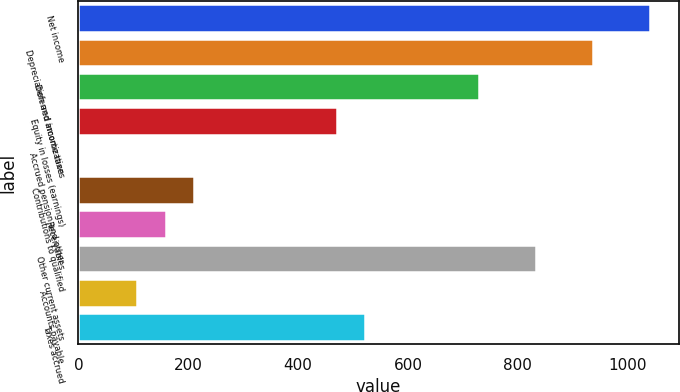Convert chart. <chart><loc_0><loc_0><loc_500><loc_500><bar_chart><fcel>Net income<fcel>Depreciation and amortization<fcel>Deferred income taxes<fcel>Equity in losses (earnings)<fcel>Accrued pension and other<fcel>Contributions to qualified<fcel>Receivables<fcel>Other current assets<fcel>Accounts payable<fcel>Taxes accrued<nl><fcel>1041<fcel>937.2<fcel>729.6<fcel>470.1<fcel>3<fcel>210.6<fcel>158.7<fcel>833.4<fcel>106.8<fcel>522<nl></chart> 